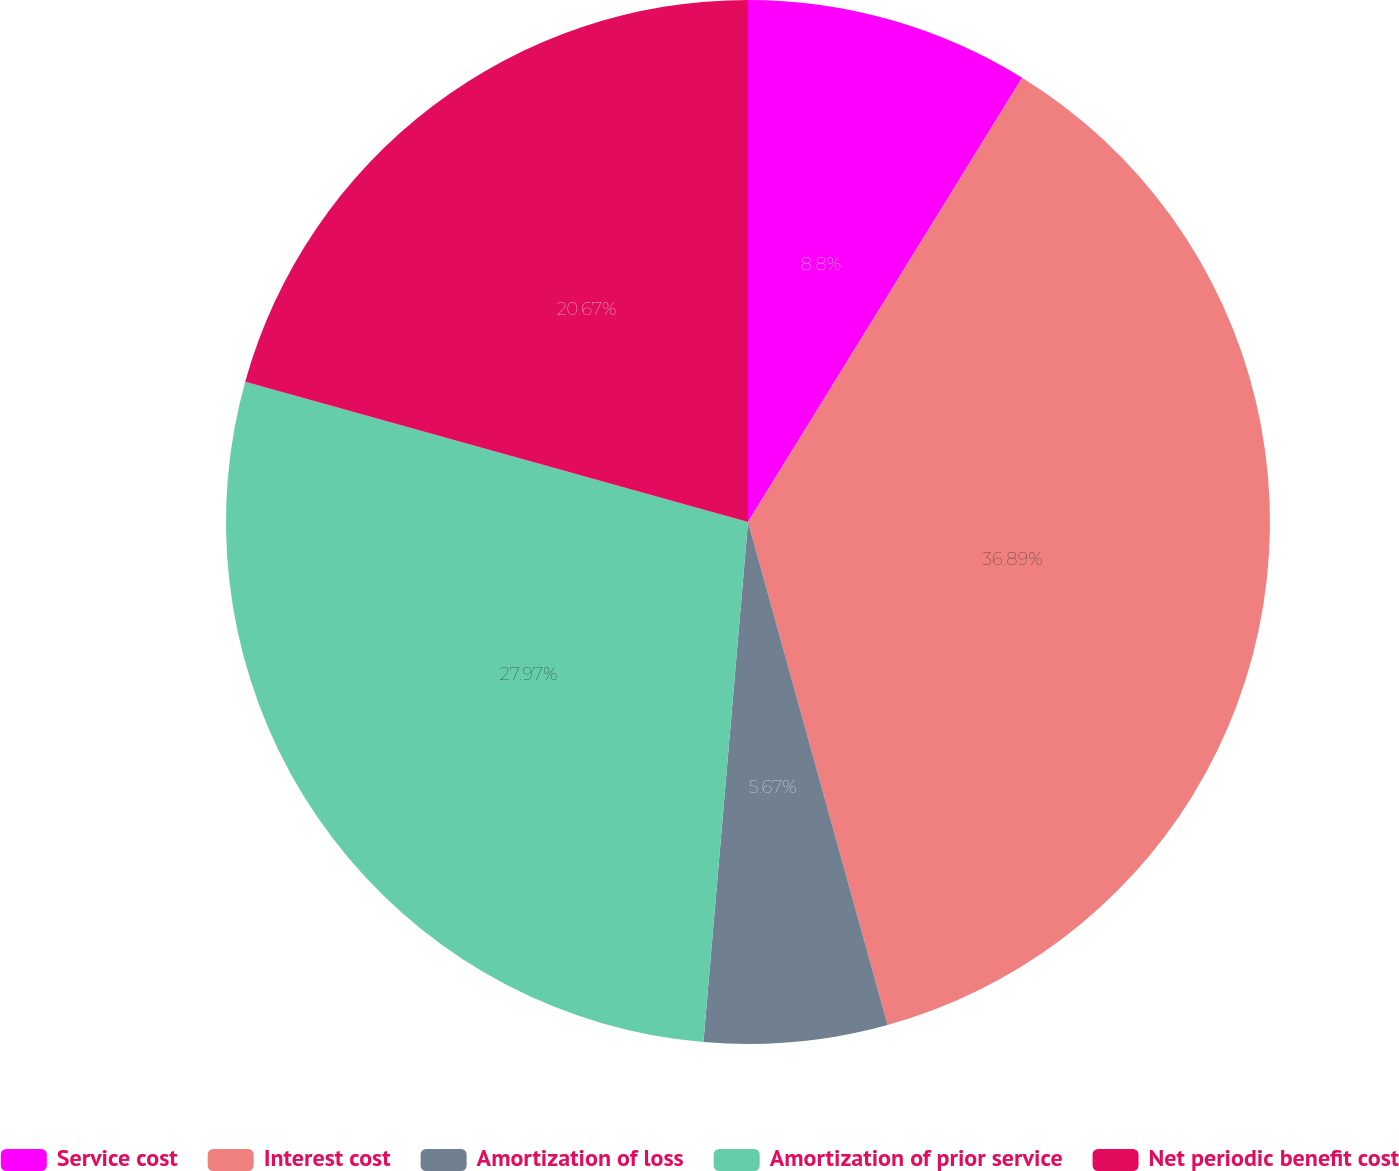Convert chart to OTSL. <chart><loc_0><loc_0><loc_500><loc_500><pie_chart><fcel>Service cost<fcel>Interest cost<fcel>Amortization of loss<fcel>Amortization of prior service<fcel>Net periodic benefit cost<nl><fcel>8.8%<fcel>36.89%<fcel>5.67%<fcel>27.97%<fcel>20.67%<nl></chart> 